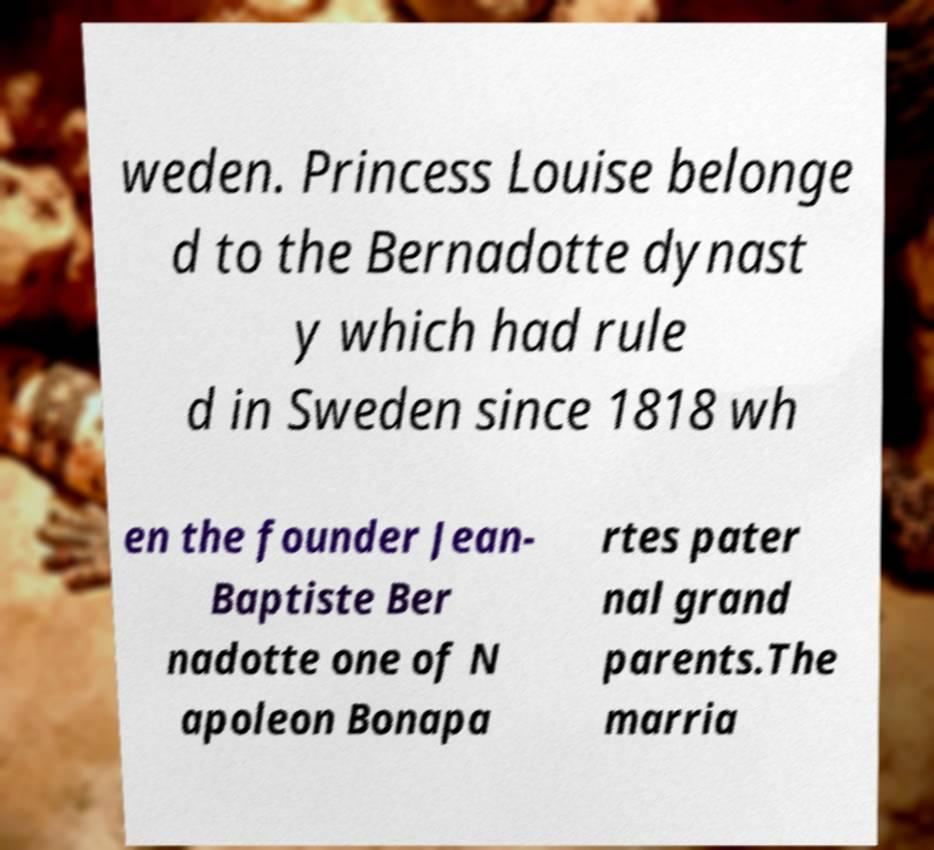Can you accurately transcribe the text from the provided image for me? weden. Princess Louise belonge d to the Bernadotte dynast y which had rule d in Sweden since 1818 wh en the founder Jean- Baptiste Ber nadotte one of N apoleon Bonapa rtes pater nal grand parents.The marria 